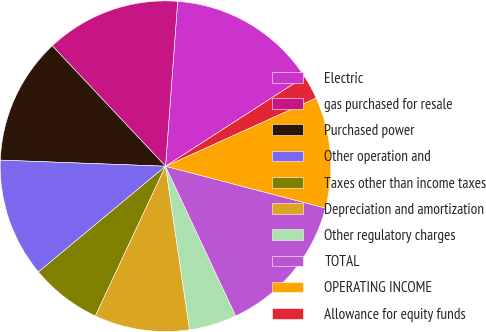Convert chart. <chart><loc_0><loc_0><loc_500><loc_500><pie_chart><fcel>Electric<fcel>gas purchased for resale<fcel>Purchased power<fcel>Other operation and<fcel>Taxes other than income taxes<fcel>Depreciation and amortization<fcel>Other regulatory charges<fcel>TOTAL<fcel>OPERATING INCOME<fcel>Allowance for equity funds<nl><fcel>14.73%<fcel>13.18%<fcel>12.4%<fcel>11.63%<fcel>6.98%<fcel>9.3%<fcel>4.65%<fcel>13.95%<fcel>10.85%<fcel>2.33%<nl></chart> 